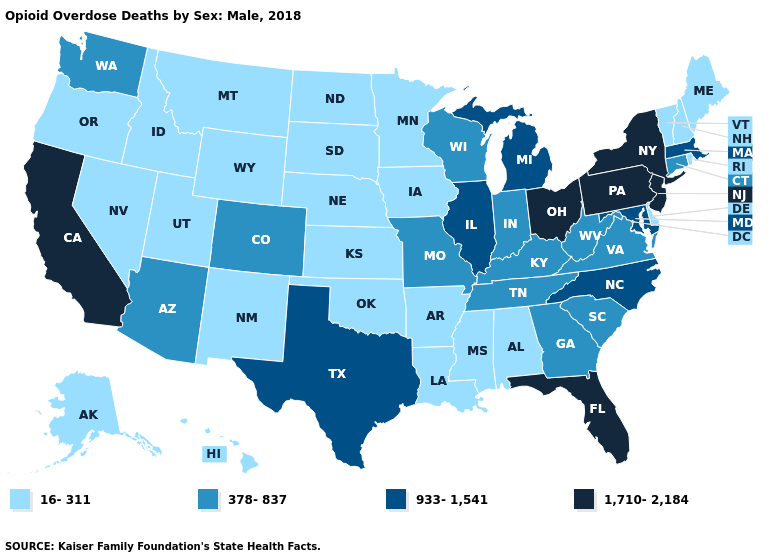Does Alabama have a higher value than Indiana?
Give a very brief answer. No. Name the states that have a value in the range 933-1,541?
Write a very short answer. Illinois, Maryland, Massachusetts, Michigan, North Carolina, Texas. Does Virginia have the lowest value in the South?
Short answer required. No. Name the states that have a value in the range 378-837?
Write a very short answer. Arizona, Colorado, Connecticut, Georgia, Indiana, Kentucky, Missouri, South Carolina, Tennessee, Virginia, Washington, West Virginia, Wisconsin. Name the states that have a value in the range 16-311?
Quick response, please. Alabama, Alaska, Arkansas, Delaware, Hawaii, Idaho, Iowa, Kansas, Louisiana, Maine, Minnesota, Mississippi, Montana, Nebraska, Nevada, New Hampshire, New Mexico, North Dakota, Oklahoma, Oregon, Rhode Island, South Dakota, Utah, Vermont, Wyoming. Does the map have missing data?
Write a very short answer. No. Is the legend a continuous bar?
Concise answer only. No. Which states hav the highest value in the MidWest?
Give a very brief answer. Ohio. Name the states that have a value in the range 1,710-2,184?
Be succinct. California, Florida, New Jersey, New York, Ohio, Pennsylvania. Name the states that have a value in the range 1,710-2,184?
Answer briefly. California, Florida, New Jersey, New York, Ohio, Pennsylvania. Name the states that have a value in the range 1,710-2,184?
Answer briefly. California, Florida, New Jersey, New York, Ohio, Pennsylvania. Among the states that border Rhode Island , which have the highest value?
Give a very brief answer. Massachusetts. Among the states that border Kentucky , which have the highest value?
Keep it brief. Ohio. Does the first symbol in the legend represent the smallest category?
Be succinct. Yes. 